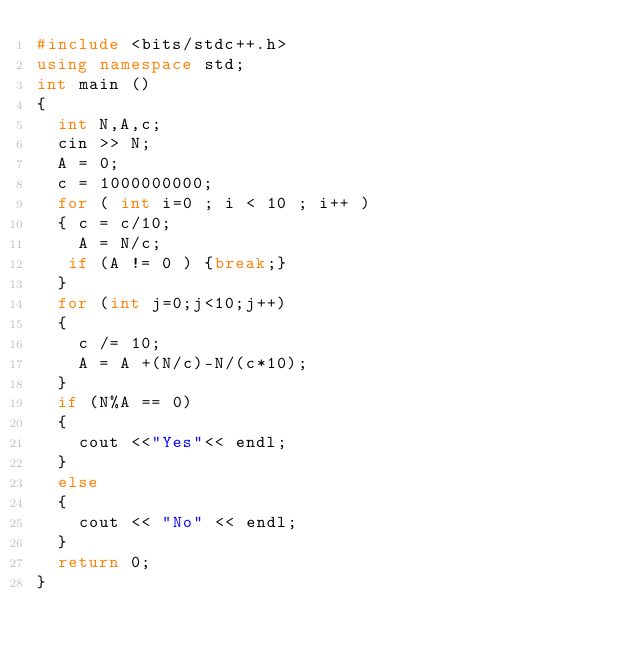Convert code to text. <code><loc_0><loc_0><loc_500><loc_500><_C++_>#include <bits/stdc++.h>
using namespace std;
int main ()
{
  int N,A,c;
  cin >> N;
  A = 0;
  c = 1000000000;
  for ( int i=0 ; i < 10 ; i++ )
  { c = c/10;
    A = N/c;
   if (A != 0 ) {break;}
  }
  for (int j=0;j<10;j++)
  {
    c /= 10;
    A = A +(N/c)-N/(c*10);
  }
  if (N%A == 0)
  {
    cout <<"Yes"<< endl;
  }
  else
  {
    cout << "No" << endl;
  }
  return 0;
}
</code> 